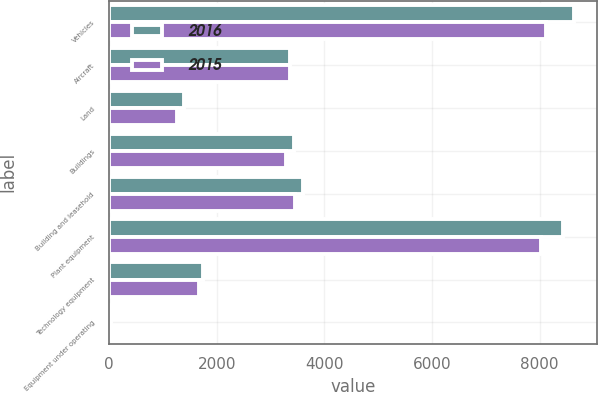Convert chart to OTSL. <chart><loc_0><loc_0><loc_500><loc_500><stacked_bar_chart><ecel><fcel>Vehicles<fcel>Aircraft<fcel>Land<fcel>Buildings<fcel>Building and leasehold<fcel>Plant equipment<fcel>Technology equipment<fcel>Equipment under operating<nl><fcel>2016<fcel>8638<fcel>3359.5<fcel>1397<fcel>3439<fcel>3612<fcel>8430<fcel>1741<fcel>29<nl><fcel>2015<fcel>8111<fcel>3359.5<fcel>1263<fcel>3280<fcel>3450<fcel>8026<fcel>1670<fcel>30<nl></chart> 